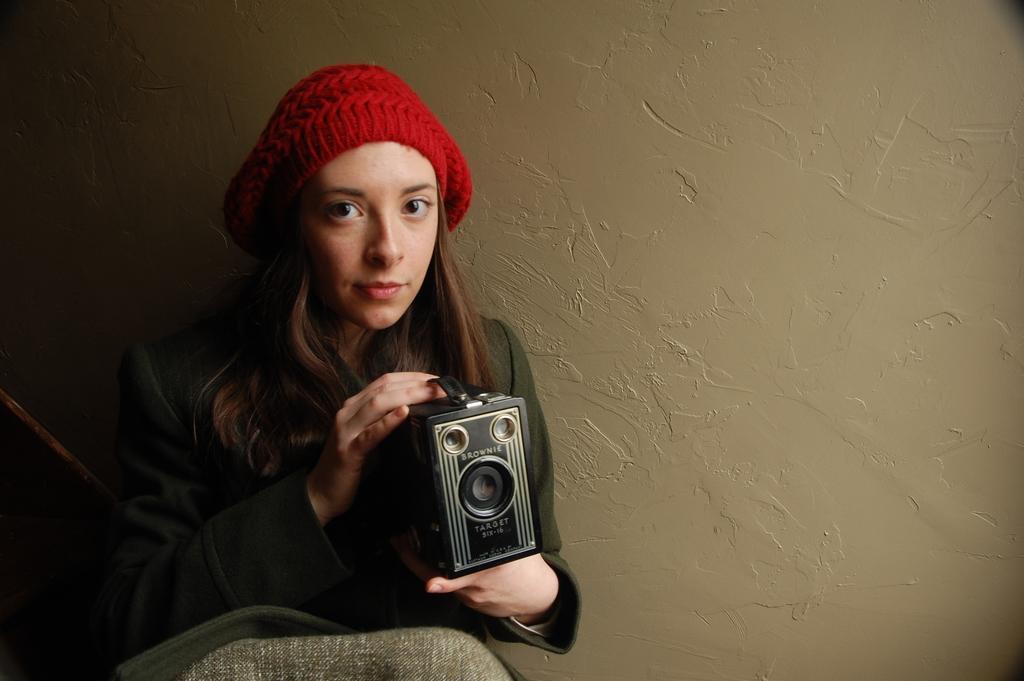In one or two sentences, can you explain what this image depicts? In the picture there is a lady holding a vintage camera,she's wore a black cap on the head. 